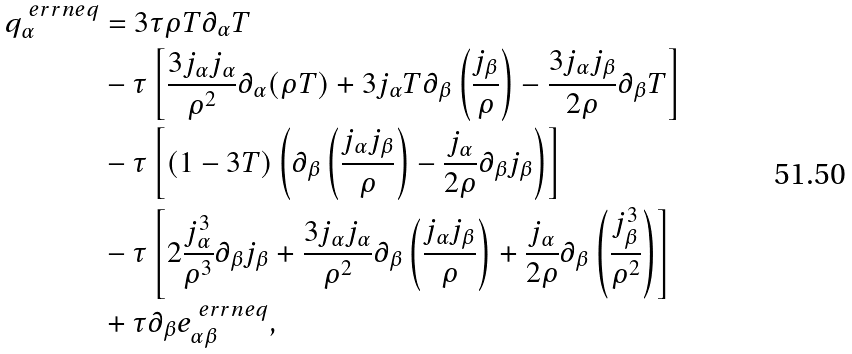Convert formula to latex. <formula><loc_0><loc_0><loc_500><loc_500>q _ { \alpha } ^ { \ e r r n e q } & = 3 \tau \rho T \partial _ { \alpha } T \\ & - \tau \left [ { \frac { 3 j _ { \alpha } j _ { \alpha } } { \rho ^ { 2 } } \partial _ { \alpha } ( \rho T ) + 3 j _ { \alpha } T \partial _ { \beta } \left ( \frac { j _ { \beta } } { \rho } \right ) - \frac { 3 j _ { \alpha } j _ { \beta } } { 2 \rho } \partial _ { \beta } T } \right ] \\ & - \tau \left [ { ( 1 - 3 T ) \left ( { \partial _ { \beta } \left ( \frac { j _ { \alpha } j _ { \beta } } { \rho } \right ) - \frac { j _ { \alpha } } { 2 \rho } \partial _ { \beta } j _ { \beta } } \right ) } \right ] \\ & - \tau \left [ { 2 \frac { j _ { \alpha } ^ { 3 } } { \rho ^ { 3 } } \partial _ { \beta } j _ { \beta } + \frac { 3 j _ { \alpha } j _ { \alpha } } { \rho ^ { 2 } } \partial _ { \beta } \left ( \frac { j _ { \alpha } j _ { \beta } } { \rho } \right ) + \frac { j _ { \alpha } } { 2 \rho } \partial _ { \beta } \left ( \frac { j _ { \beta } ^ { 3 } } { \rho ^ { 2 } } \right ) } \right ] \\ & + \tau \partial _ { \beta } e _ { \alpha \beta } ^ { \ e r r n e q } ,</formula> 